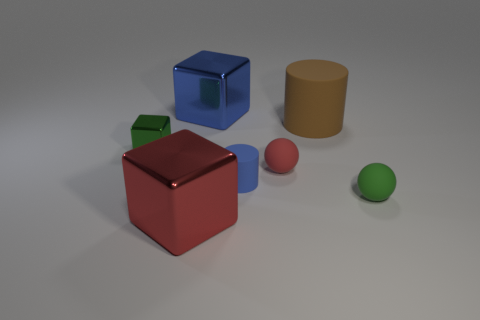Subtract all big cubes. How many cubes are left? 1 Subtract all green cubes. How many cubes are left? 2 Subtract 1 balls. How many balls are left? 1 Subtract all purple cubes. Subtract all red balls. How many cubes are left? 3 Subtract all cyan cylinders. How many gray balls are left? 0 Add 6 small blue metallic cylinders. How many small blue metallic cylinders exist? 6 Add 1 large objects. How many objects exist? 8 Subtract 1 red spheres. How many objects are left? 6 Subtract all cubes. How many objects are left? 4 Subtract all large blue metallic blocks. Subtract all small cylinders. How many objects are left? 5 